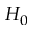Convert formula to latex. <formula><loc_0><loc_0><loc_500><loc_500>H _ { 0 }</formula> 